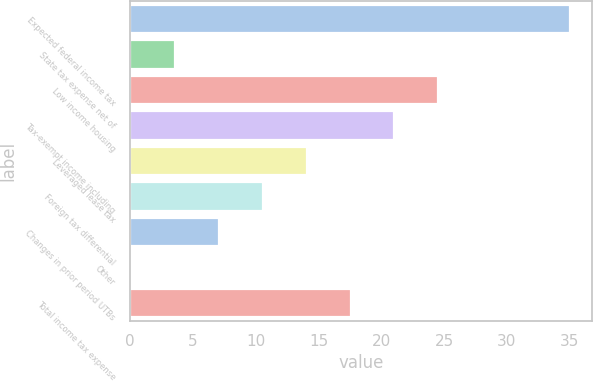Convert chart. <chart><loc_0><loc_0><loc_500><loc_500><bar_chart><fcel>Expected federal income tax<fcel>State tax expense net of<fcel>Low income housing<fcel>Tax-exempt income including<fcel>Leveraged lease tax<fcel>Foreign tax differential<fcel>Changes in prior period UTBs<fcel>Other<fcel>Total income tax expense<nl><fcel>35<fcel>3.59<fcel>24.53<fcel>21.04<fcel>14.06<fcel>10.57<fcel>7.08<fcel>0.1<fcel>17.55<nl></chart> 